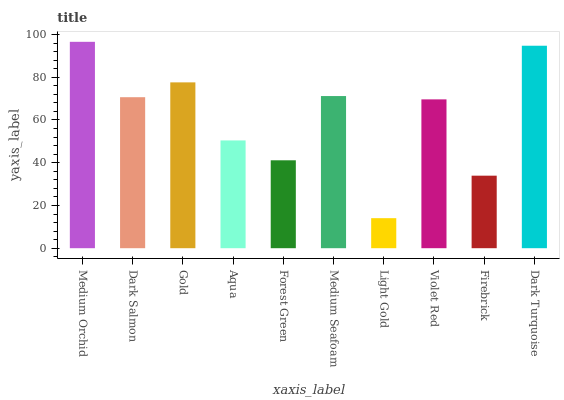Is Light Gold the minimum?
Answer yes or no. Yes. Is Medium Orchid the maximum?
Answer yes or no. Yes. Is Dark Salmon the minimum?
Answer yes or no. No. Is Dark Salmon the maximum?
Answer yes or no. No. Is Medium Orchid greater than Dark Salmon?
Answer yes or no. Yes. Is Dark Salmon less than Medium Orchid?
Answer yes or no. Yes. Is Dark Salmon greater than Medium Orchid?
Answer yes or no. No. Is Medium Orchid less than Dark Salmon?
Answer yes or no. No. Is Dark Salmon the high median?
Answer yes or no. Yes. Is Violet Red the low median?
Answer yes or no. Yes. Is Medium Orchid the high median?
Answer yes or no. No. Is Light Gold the low median?
Answer yes or no. No. 